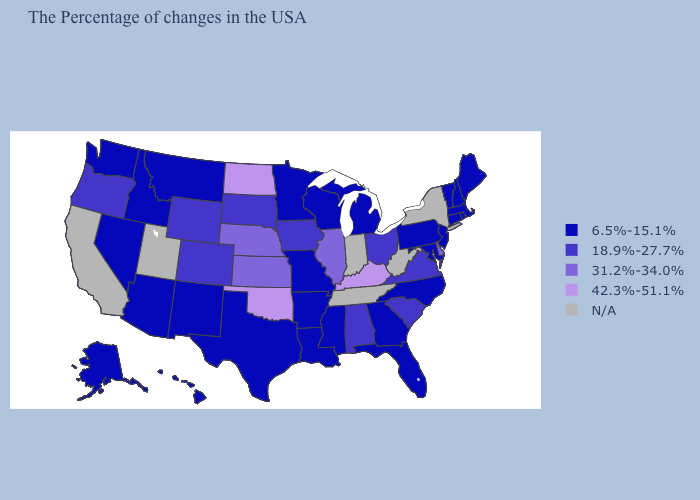What is the value of Maryland?
Be succinct. 6.5%-15.1%. What is the value of Kansas?
Answer briefly. 31.2%-34.0%. What is the highest value in the West ?
Write a very short answer. 18.9%-27.7%. Does Michigan have the lowest value in the MidWest?
Give a very brief answer. Yes. Name the states that have a value in the range 31.2%-34.0%?
Concise answer only. Delaware, Illinois, Kansas, Nebraska. Which states hav the highest value in the South?
Quick response, please. Kentucky, Oklahoma. Does Nevada have the lowest value in the West?
Be succinct. Yes. Name the states that have a value in the range N/A?
Keep it brief. New York, West Virginia, Indiana, Tennessee, Utah, California. What is the value of Washington?
Keep it brief. 6.5%-15.1%. What is the lowest value in the MidWest?
Answer briefly. 6.5%-15.1%. Among the states that border Nevada , which have the lowest value?
Keep it brief. Arizona, Idaho. What is the value of North Carolina?
Short answer required. 6.5%-15.1%. 